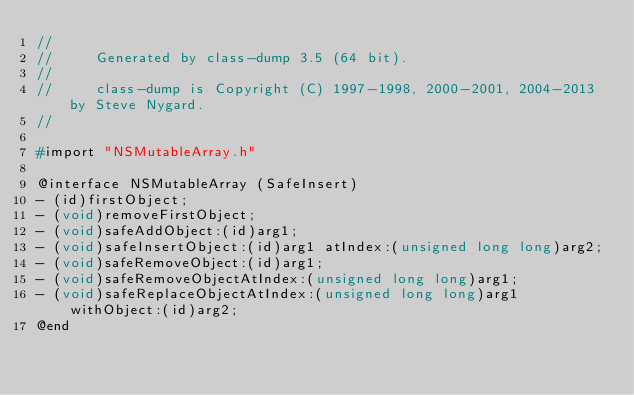Convert code to text. <code><loc_0><loc_0><loc_500><loc_500><_C_>//
//     Generated by class-dump 3.5 (64 bit).
//
//     class-dump is Copyright (C) 1997-1998, 2000-2001, 2004-2013 by Steve Nygard.
//

#import "NSMutableArray.h"

@interface NSMutableArray (SafeInsert)
- (id)firstObject;
- (void)removeFirstObject;
- (void)safeAddObject:(id)arg1;
- (void)safeInsertObject:(id)arg1 atIndex:(unsigned long long)arg2;
- (void)safeRemoveObject:(id)arg1;
- (void)safeRemoveObjectAtIndex:(unsigned long long)arg1;
- (void)safeReplaceObjectAtIndex:(unsigned long long)arg1 withObject:(id)arg2;
@end

</code> 